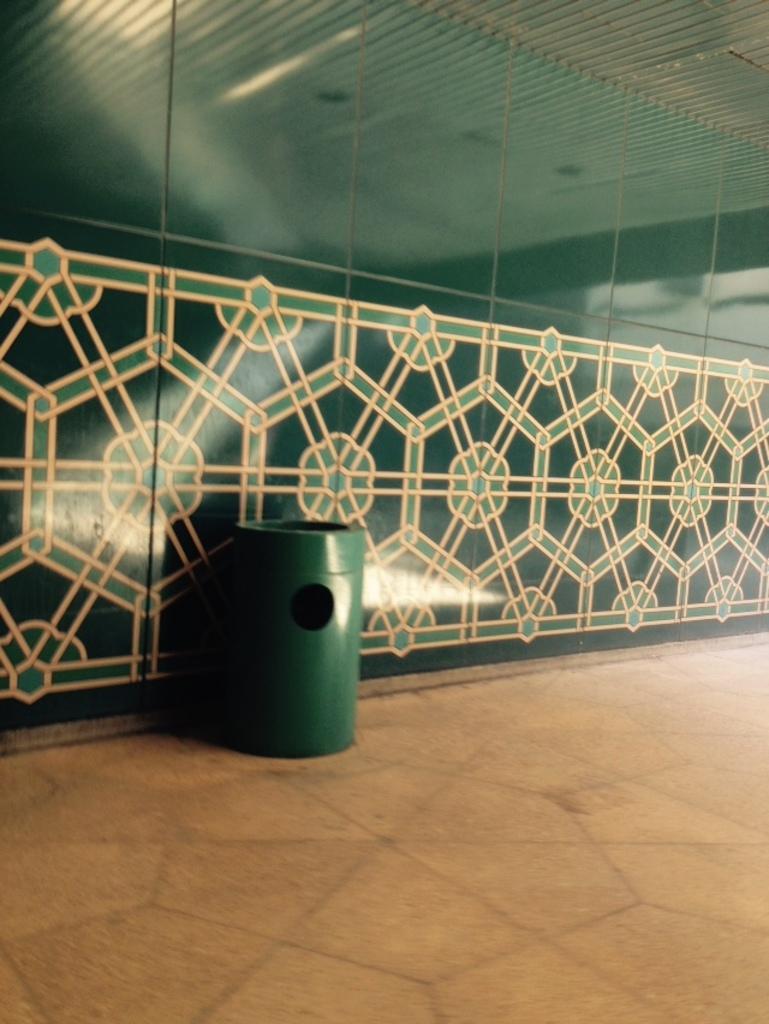Please provide a concise description of this image. This picture shows a wall and we see a dustbin. The dustbin is green in color. 